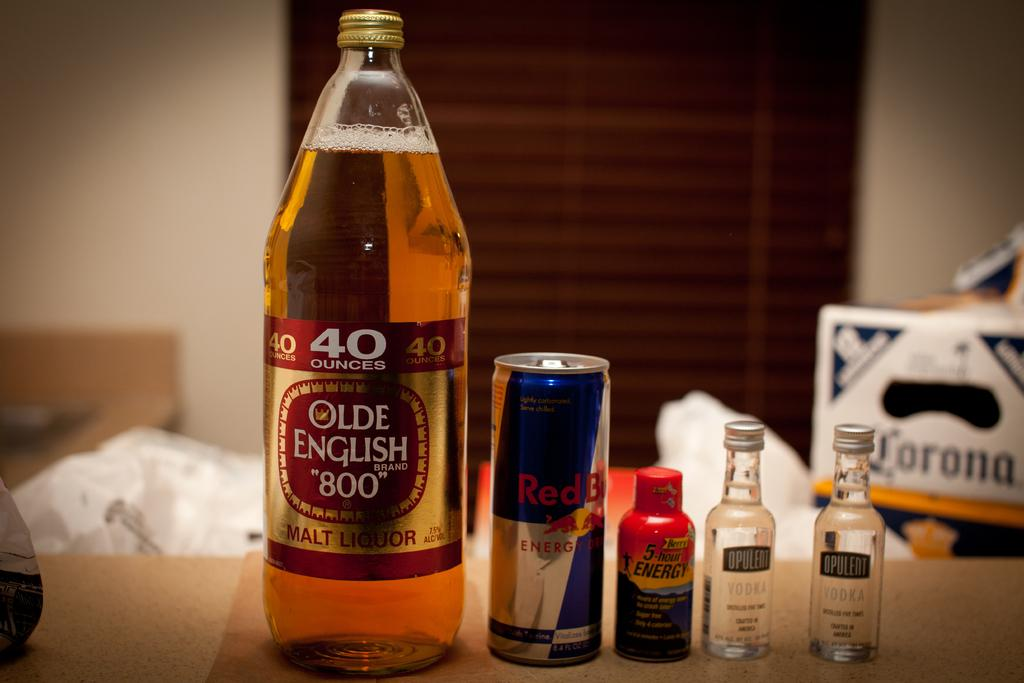<image>
Summarize the visual content of the image. The box in the back is holding Corona beer 